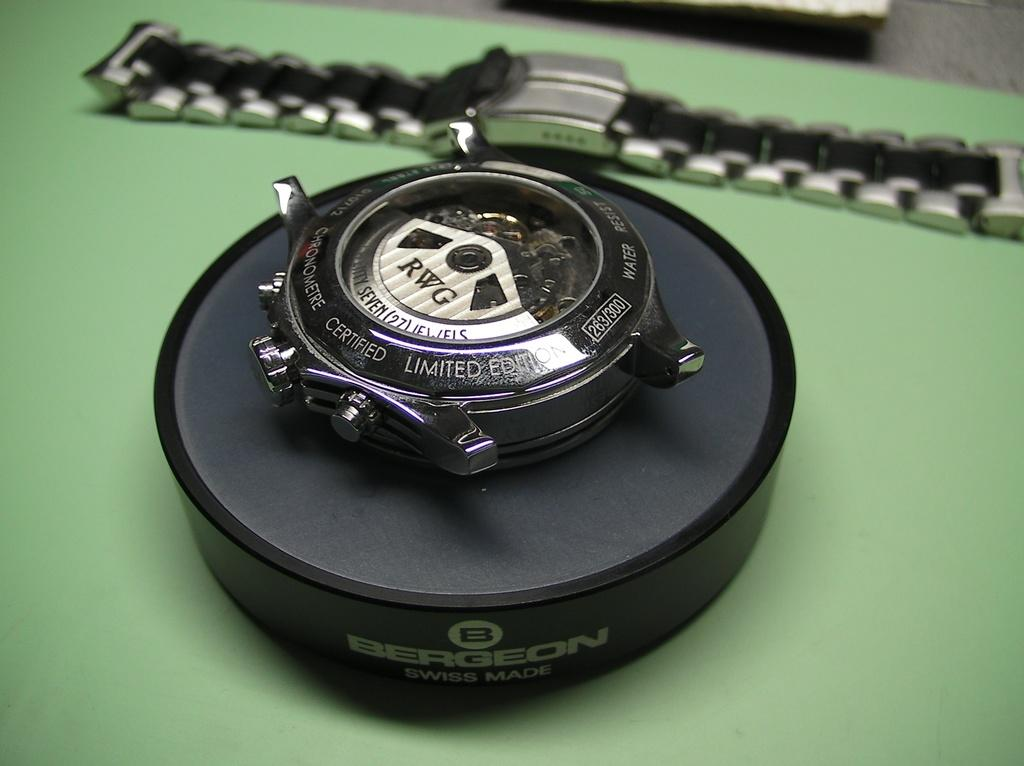<image>
Create a compact narrative representing the image presented. A RWG watch is pulled apart and on display. 